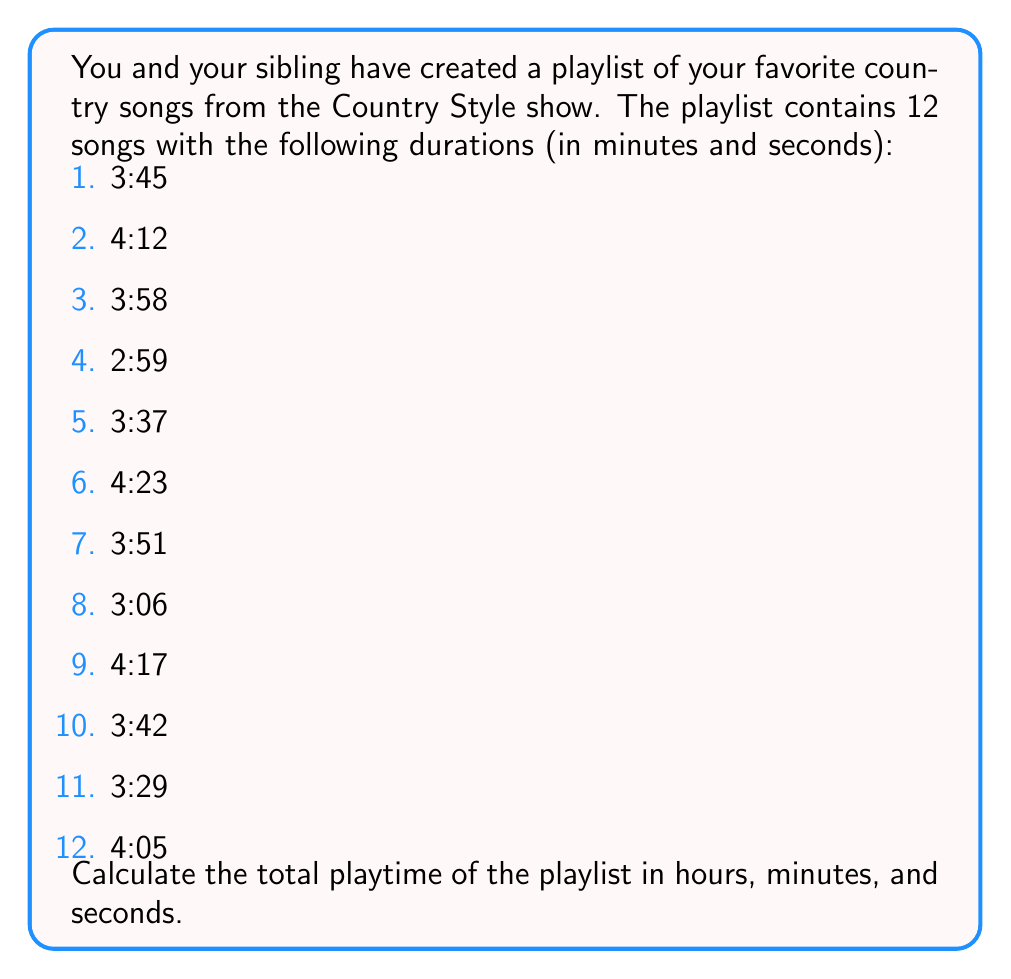Can you answer this question? To solve this problem, we'll follow these steps:

1. Convert all times to seconds
2. Sum up the total seconds
3. Convert the total seconds back to hours, minutes, and seconds

Step 1: Convert all times to seconds
For each song, we'll use the formula: $\text{Total seconds} = \text{Minutes} \times 60 + \text{Seconds}$

1. $3:45 = 3 \times 60 + 45 = 225$ seconds
2. $4:12 = 4 \times 60 + 12 = 252$ seconds
3. $3:58 = 3 \times 60 + 58 = 238$ seconds
4. $2:59 = 2 \times 60 + 59 = 179$ seconds
5. $3:37 = 3 \times 60 + 37 = 217$ seconds
6. $4:23 = 4 \times 60 + 23 = 263$ seconds
7. $3:51 = 3 \times 60 + 51 = 231$ seconds
8. $3:06 = 3 \times 60 + 6 = 186$ seconds
9. $4:17 = 4 \times 60 + 17 = 257$ seconds
10. $3:42 = 3 \times 60 + 42 = 222$ seconds
11. $3:29 = 3 \times 60 + 29 = 209$ seconds
12. $4:05 = 4 \times 60 + 5 = 245$ seconds

Step 2: Sum up the total seconds
$$\text{Total seconds} = 225 + 252 + 238 + 179 + 217 + 263 + 231 + 186 + 257 + 222 + 209 + 245 = 2724 \text{ seconds}$$

Step 3: Convert the total seconds back to hours, minutes, and seconds
- Hours: $\lfloor \frac{2724}{3600} \rfloor = 0$ (integer division)
- Remaining seconds: $2724 \bmod 3600 = 2724$
- Minutes: $\lfloor \frac{2724}{60} \rfloor = 45$
- Remaining seconds: $2724 \bmod 60 = 24$

Therefore, the total playtime is 0 hours, 45 minutes, and 24 seconds.
Answer: The total playtime of the country music playlist is 0:45:24 (45 minutes and 24 seconds). 